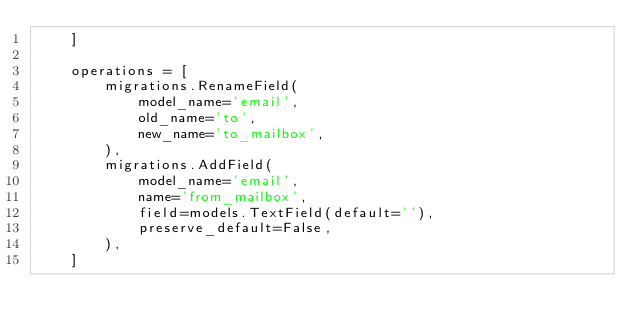Convert code to text. <code><loc_0><loc_0><loc_500><loc_500><_Python_>    ]

    operations = [
        migrations.RenameField(
            model_name='email',
            old_name='to',
            new_name='to_mailbox',
        ),
        migrations.AddField(
            model_name='email',
            name='from_mailbox',
            field=models.TextField(default=''),
            preserve_default=False,
        ),
    ]
</code> 